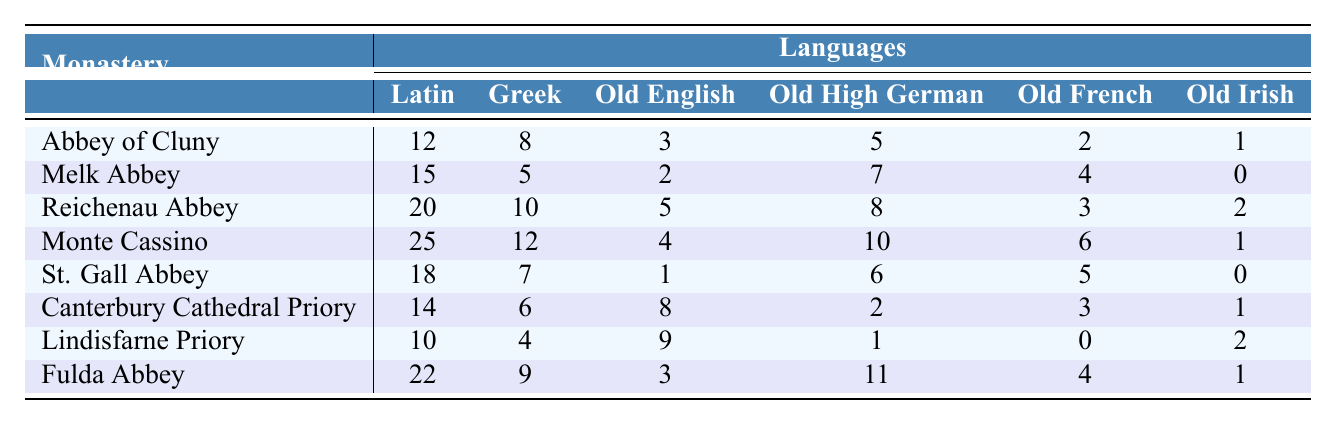What is the highest frequency of manuscripts in Latin found at a monastery? Looking at the first column (Latin) across all the monasteries, the highest value is in the Monte Cassino row with a frequency of 25.
Answer: 25 Which monastery has the least frequency of manuscripts in Old Irish? By scanning the last column (Old Irish), Lindisfarne Priory has the least frequency with a value of 2.
Answer: 2 What is the sum of manuscript frequencies for Latin in all monasteries? Adding the values in the Latin column: 12 + 15 + 20 + 25 + 18 + 14 + 10 + 22 = 126.
Answer: 126 Which language had the highest average frequency of manuscripts across all monasteries? Calculating the averages: Latin (126/8=15.75), Greek (57/8=7.125), Old English (36/8=4.5), Old High German (49/8=6.125), Old French (24/8=3), and Old Irish (10/8=1.25). The highest average is for Latin at 15.75.
Answer: Latin Did Melk Abbey have any manuscripts in Old Irish? Checking the Old Irish column for Melk Abbey, the value is 0, indicating that there were no manuscripts in Old Irish.
Answer: No Which two monasteries had a total of more than 20 manuscripts in Old High German? Adding the frequencies in Old High German: Monte Cassino (10) + Fulda Abbey (11) = 21, which exceeds 20. These are the two monasteries.
Answer: Monte Cassino and Fulda Abbey How many more manuscripts are there in Latin at Reichenau Abbey compared to Canterbury Cathedral Priory? The frequency for Latin at Reichenau Abbey is 20; for Canterbury Cathedral Priory, it's 14. The difference is 20 - 14 = 6.
Answer: 6 Which monastery had the highest frequency of bilingual manuscripts in the 12th century? Looking for the maximum value in all language columns for each monastery in the 12th century; Monte Cassino shows the highest frequency across all languages at 25.
Answer: Monte Cassino Is Old French represented in manuscripts at the Lindisfarne Priory? The value for Old French at Lindisfarne Priory is 0, indicating there are no manuscripts in Old French.
Answer: No What is the median frequency of manuscripts in Greek across all monasteries? Listing the frequencies for Greek: 8, 5, 10, 12, 7, 6, 4, 9 reordered gives 4, 5, 6, 7, 8, 9, 10, 12. The median is the average of 7 and 8, which is (7 + 8) / 2 = 7.5.
Answer: 7.5 